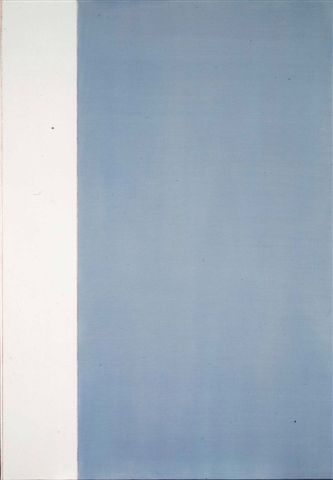If this image were the doorway to another world, what would that world be like? Imagine stepping into a world where the landscape mirrors the minimalist aesthetic of the artwork. Entering through the white section, you find yourself in a serene, vast expanse, reminiscent of untouched snowfields or a blank canvas waiting for creation. Here, everything is calm, silent, and pure, encouraging introspection and peace. Transitioning to the blue section, the gradient effect introduces you to a tranquil sky or a still, deep ocean. As you ascend, the colors lighten, symbolizing enlightenment and awakening. This world might be one of balance, where tranquility and purity meet, offering a perfect escape for meditation and inner discovery. 